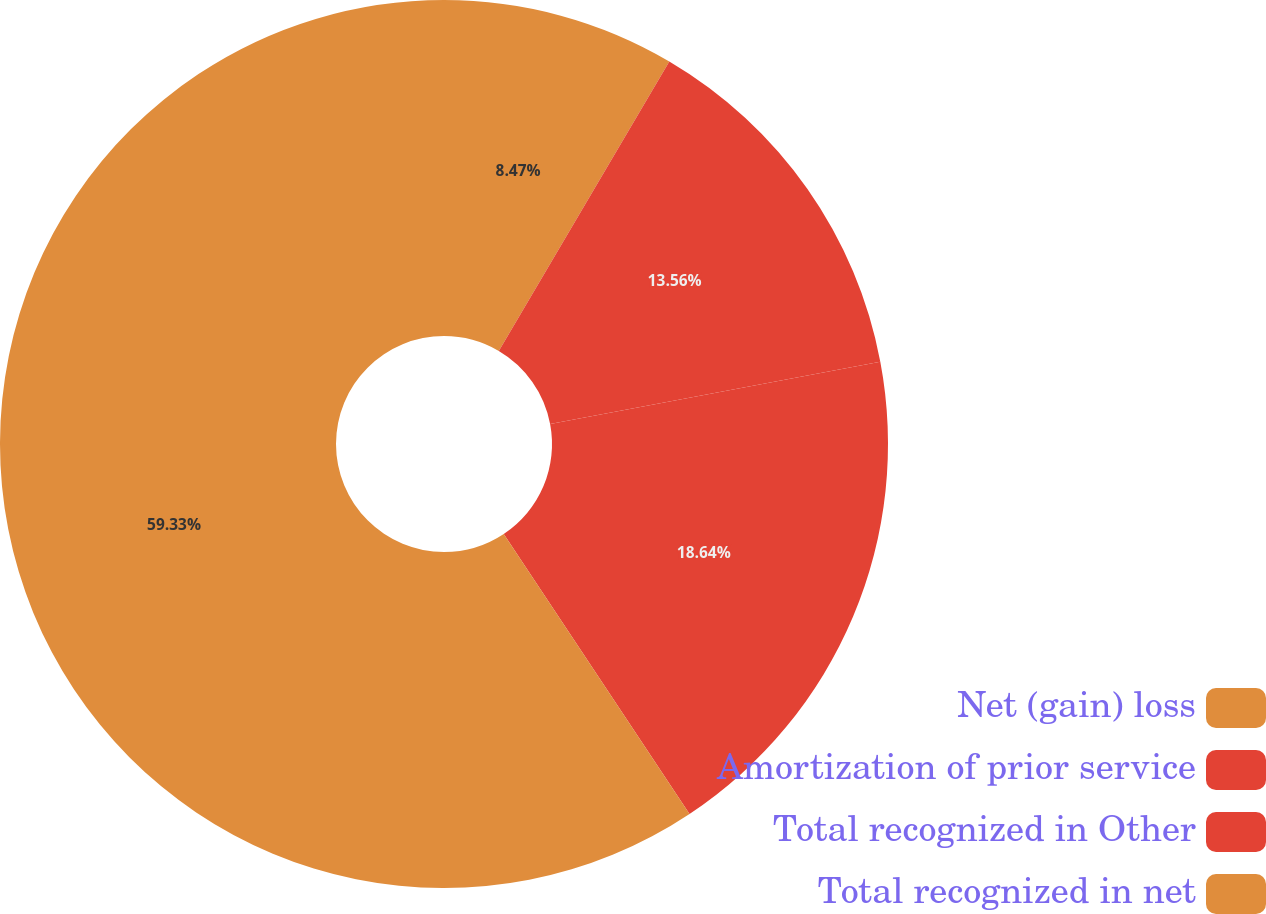Convert chart to OTSL. <chart><loc_0><loc_0><loc_500><loc_500><pie_chart><fcel>Net (gain) loss<fcel>Amortization of prior service<fcel>Total recognized in Other<fcel>Total recognized in net<nl><fcel>8.47%<fcel>13.56%<fcel>18.64%<fcel>59.32%<nl></chart> 